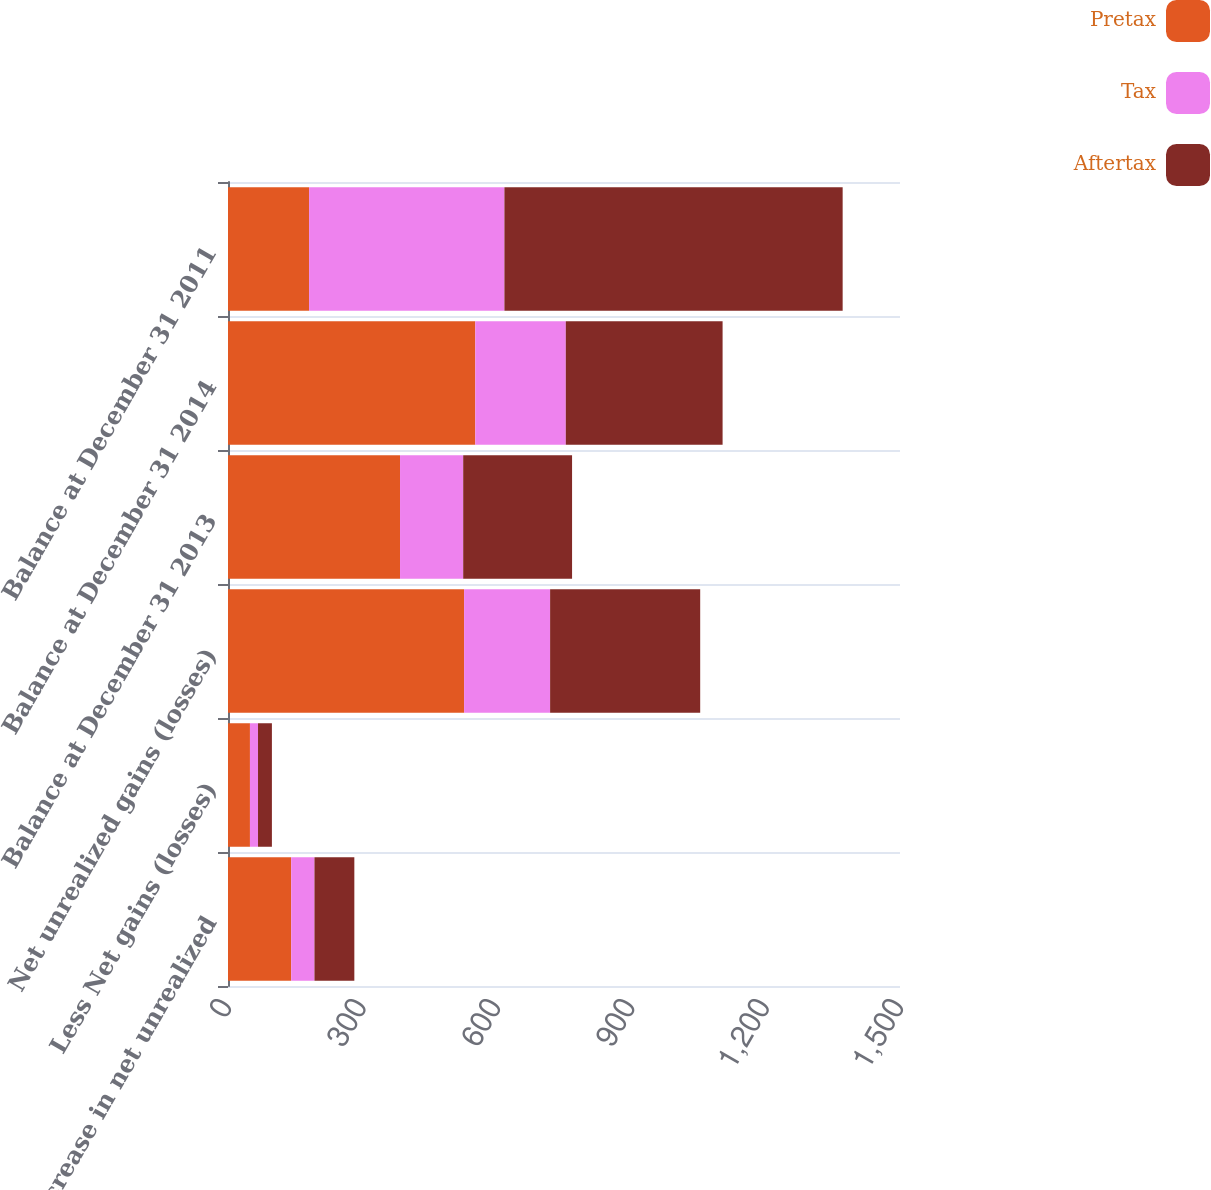Convert chart. <chart><loc_0><loc_0><loc_500><loc_500><stacked_bar_chart><ecel><fcel>Increase in net unrealized<fcel>Less Net gains (losses)<fcel>Net unrealized gains (losses)<fcel>Balance at December 31 2013<fcel>Balance at December 31 2014<fcel>Balance at December 31 2011<nl><fcel>Pretax<fcel>141<fcel>49<fcel>527<fcel>384<fcel>552<fcel>181<nl><fcel>Tax<fcel>52<fcel>18<fcel>192<fcel>141<fcel>202<fcel>436<nl><fcel>Aftertax<fcel>89<fcel>31<fcel>335<fcel>243<fcel>350<fcel>755<nl></chart> 